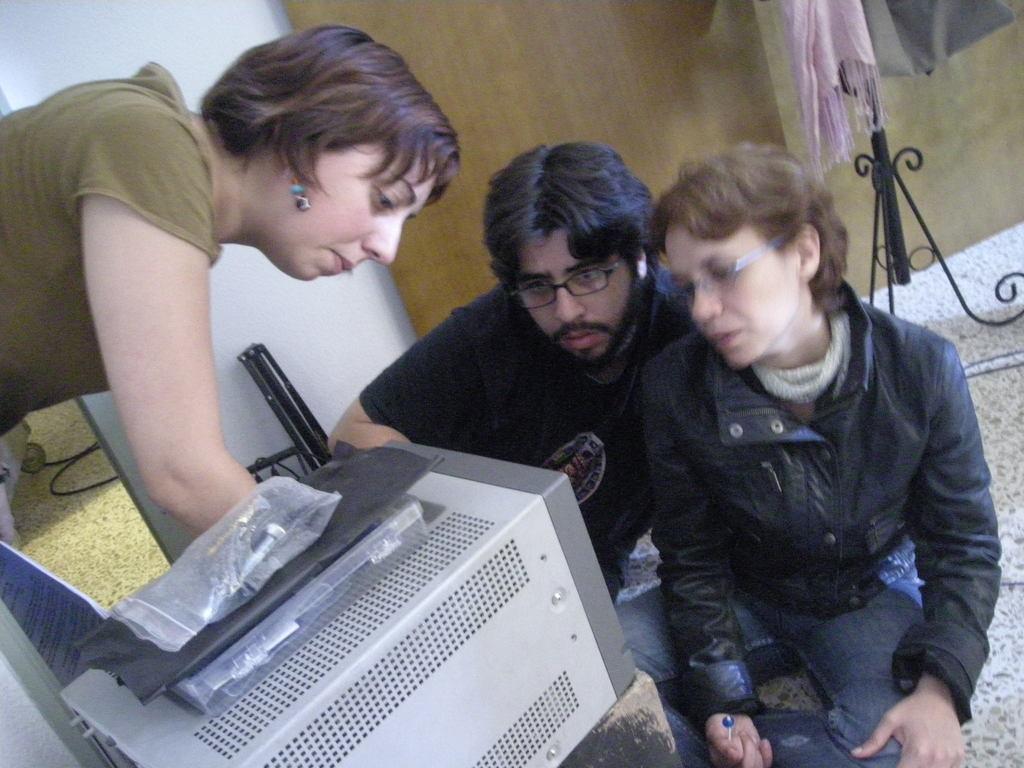How would you summarize this image in a sentence or two? The picture is taken inside a room. In the foreground of the picture we can see people, box, cover and some electronic gadgets. In the background we can see wall, stand, cloth and other objects. 